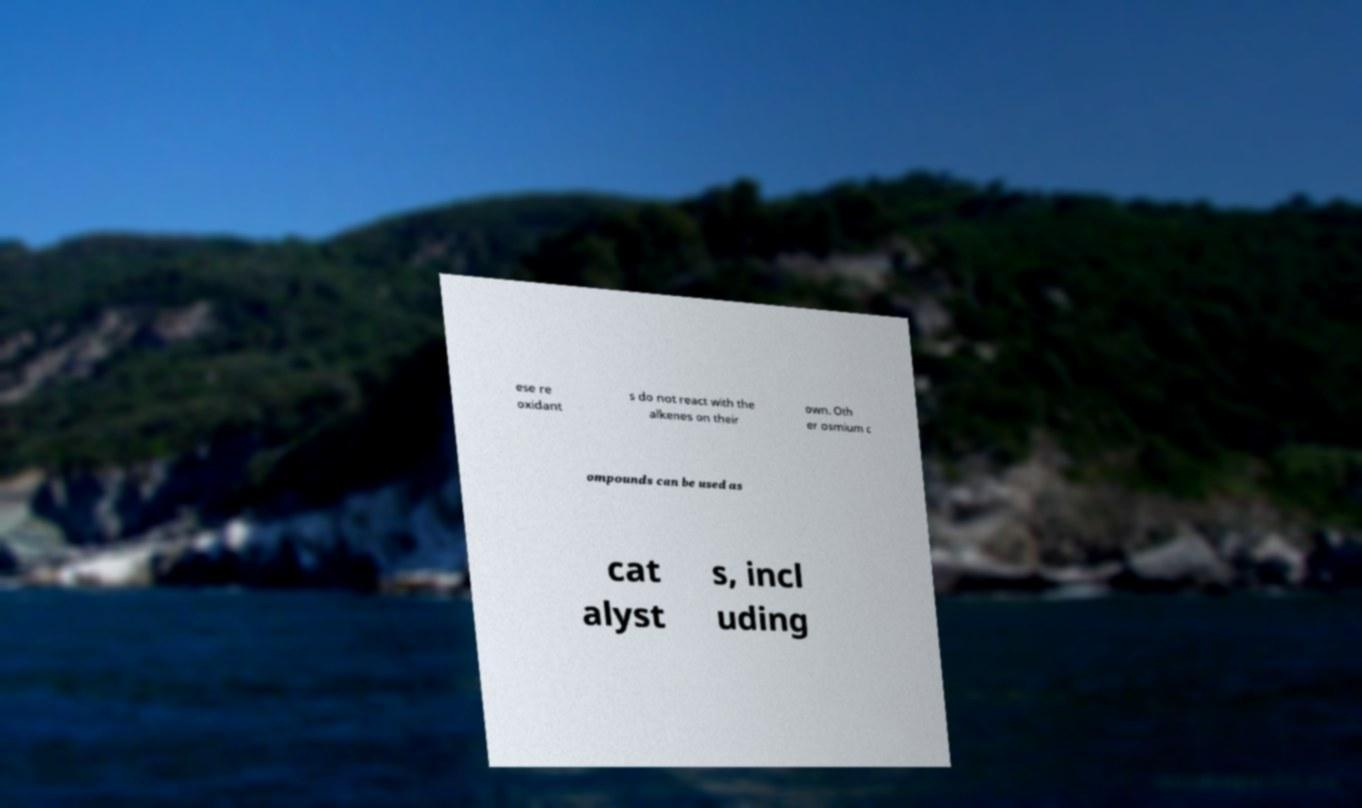Could you assist in decoding the text presented in this image and type it out clearly? ese re oxidant s do not react with the alkenes on their own. Oth er osmium c ompounds can be used as cat alyst s, incl uding 